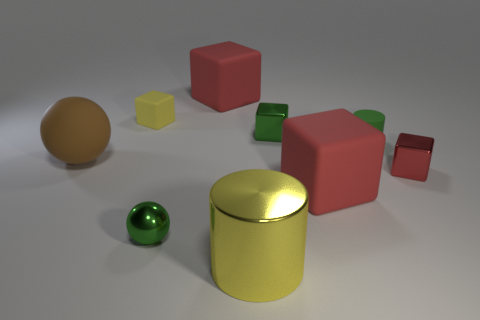Subtract all small green shiny blocks. How many blocks are left? 4 Subtract all blue cylinders. How many red blocks are left? 3 Add 1 cubes. How many objects exist? 10 Subtract all red blocks. How many blocks are left? 2 Subtract 1 cubes. How many cubes are left? 4 Subtract all cubes. How many objects are left? 4 Add 5 tiny metal cubes. How many tiny metal cubes are left? 7 Add 3 small red matte objects. How many small red matte objects exist? 3 Subtract 0 cyan balls. How many objects are left? 9 Subtract all yellow blocks. Subtract all gray balls. How many blocks are left? 4 